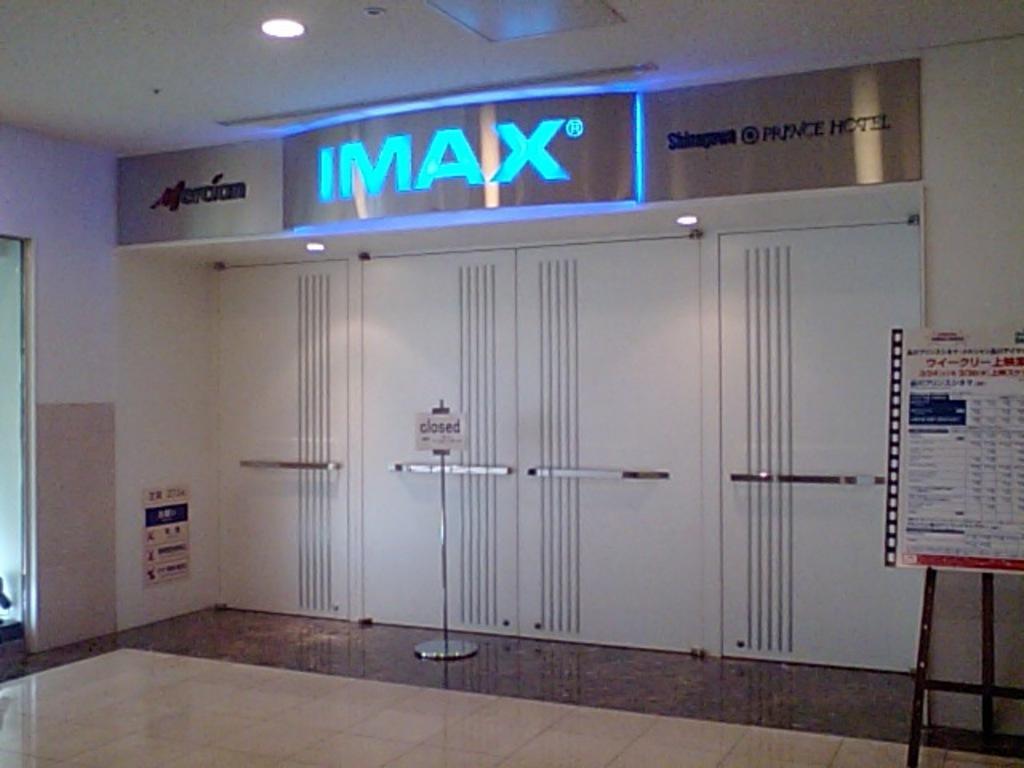How would you summarize this image in a sentence or two? This picture is taken inside the room. In this image, on the right side, we can see a board, on the board, we can see some text written on it. On the left side, we can see a glass window. In the middle of the image, we can see a metal pole and a board, on the board, we can see some text written on it. At the top, we can see a roof with few lights. 